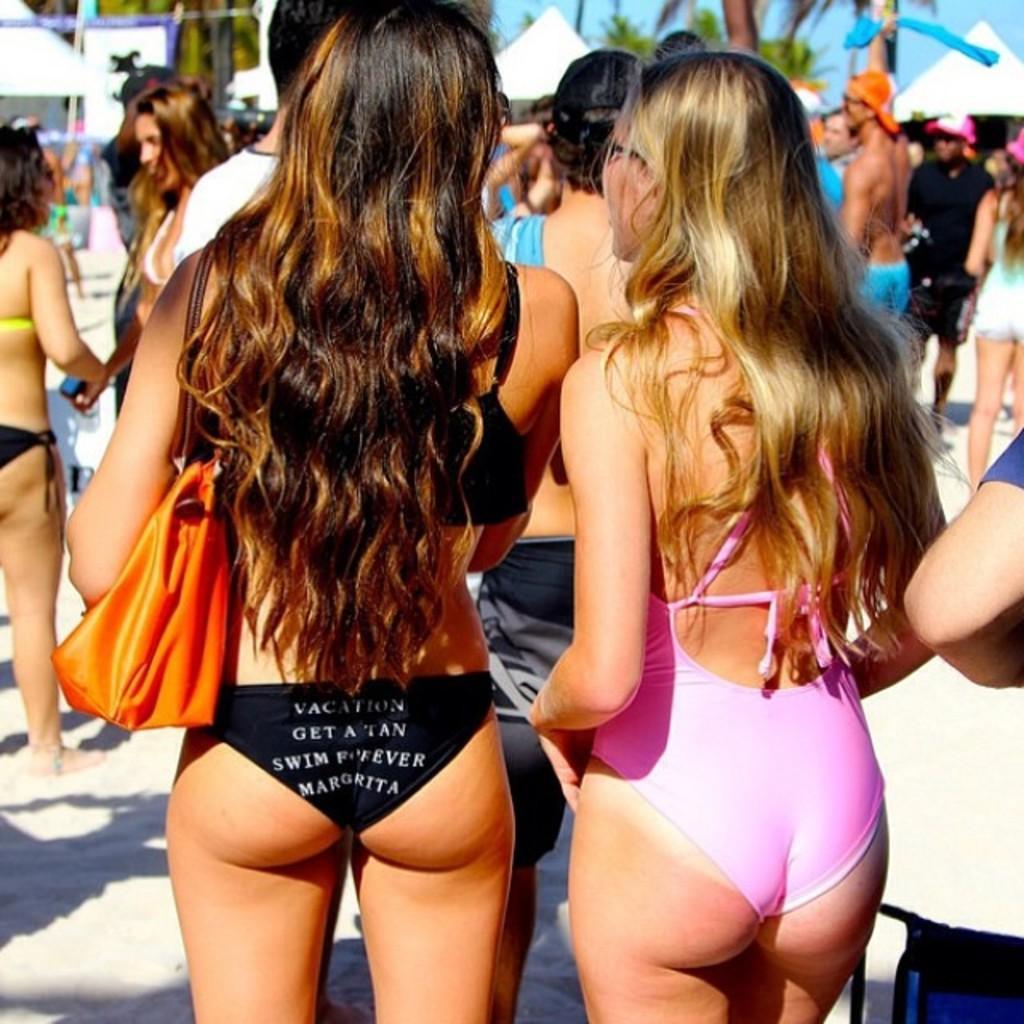Describe this image in one or two sentences. There are people standing and she is carrying a bag. In the background we can see tents, trees and sky. 